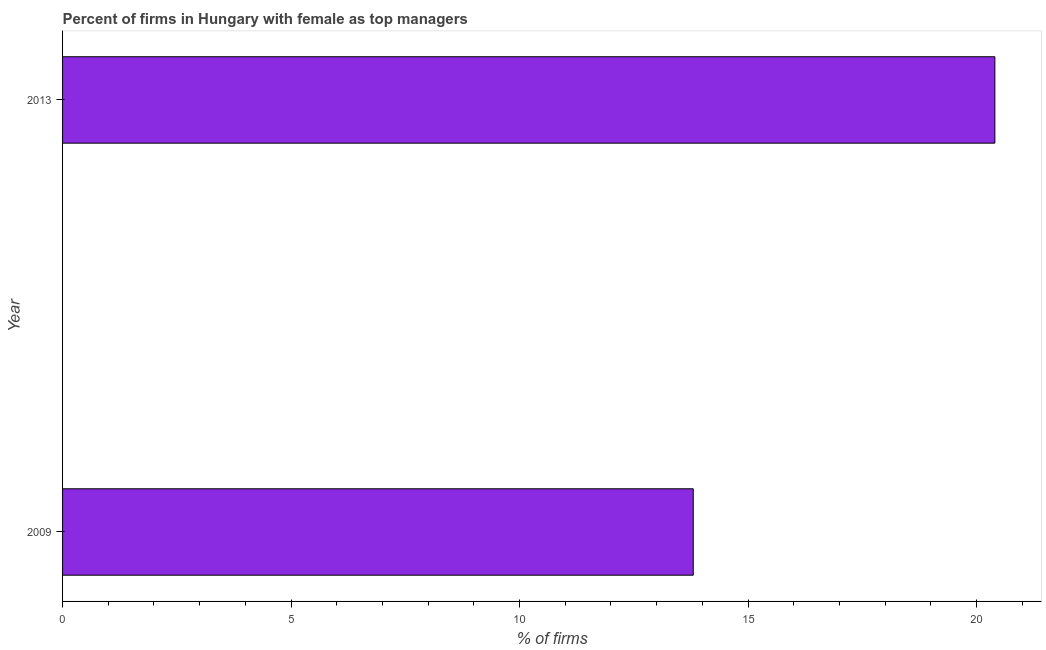Does the graph contain grids?
Your response must be concise. No. What is the title of the graph?
Provide a succinct answer. Percent of firms in Hungary with female as top managers. What is the label or title of the X-axis?
Give a very brief answer. % of firms. Across all years, what is the maximum percentage of firms with female as top manager?
Your answer should be compact. 20.4. What is the sum of the percentage of firms with female as top manager?
Keep it short and to the point. 34.2. What is the median percentage of firms with female as top manager?
Provide a succinct answer. 17.1. In how many years, is the percentage of firms with female as top manager greater than 18 %?
Your answer should be compact. 1. What is the ratio of the percentage of firms with female as top manager in 2009 to that in 2013?
Ensure brevity in your answer.  0.68. In how many years, is the percentage of firms with female as top manager greater than the average percentage of firms with female as top manager taken over all years?
Ensure brevity in your answer.  1. How many bars are there?
Give a very brief answer. 2. How many years are there in the graph?
Keep it short and to the point. 2. What is the difference between two consecutive major ticks on the X-axis?
Provide a short and direct response. 5. Are the values on the major ticks of X-axis written in scientific E-notation?
Offer a terse response. No. What is the % of firms in 2013?
Offer a very short reply. 20.4. What is the ratio of the % of firms in 2009 to that in 2013?
Your response must be concise. 0.68. 